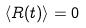<formula> <loc_0><loc_0><loc_500><loc_500>\langle R ( t ) \rangle = 0</formula> 